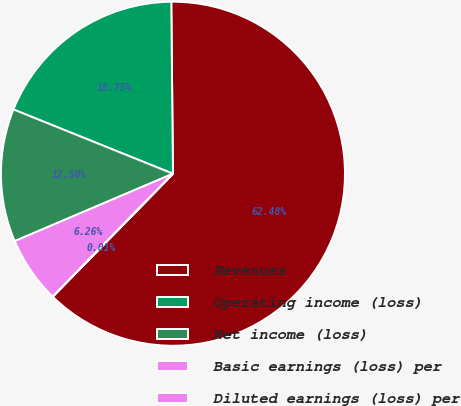<chart> <loc_0><loc_0><loc_500><loc_500><pie_chart><fcel>Revenues<fcel>Operating income (loss)<fcel>Net income (loss)<fcel>Basic earnings (loss) per<fcel>Diluted earnings (loss) per<nl><fcel>62.47%<fcel>18.75%<fcel>12.5%<fcel>6.26%<fcel>0.01%<nl></chart> 